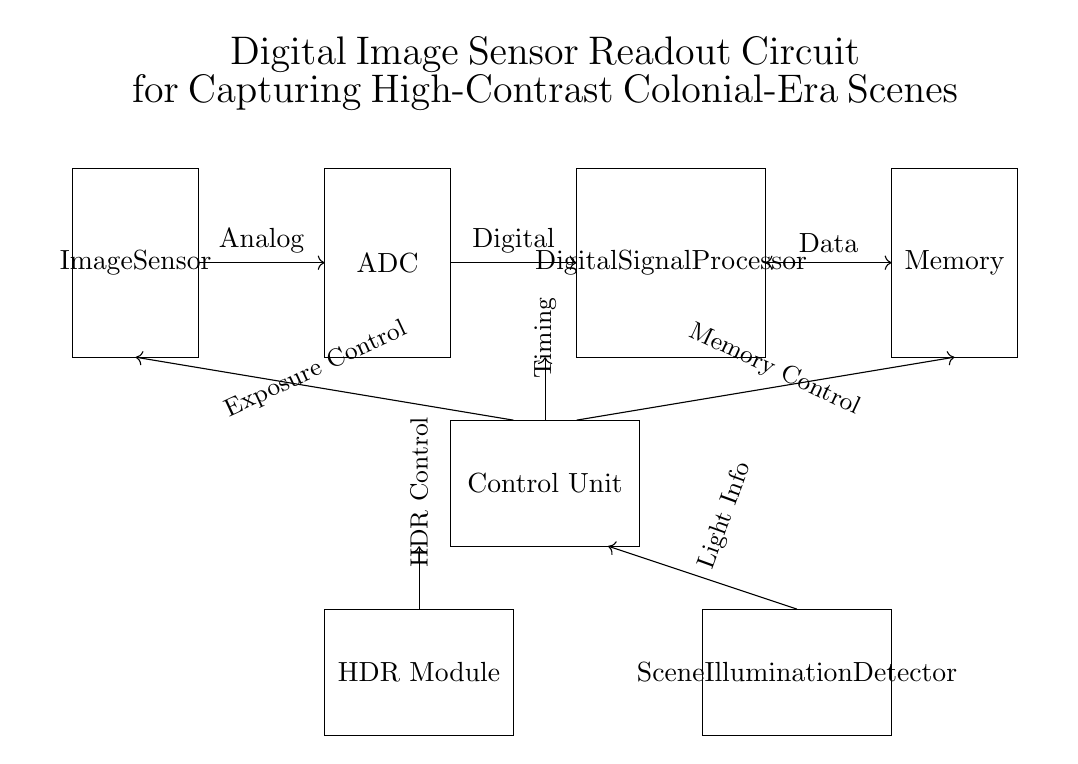What is the main function of the image sensor? The main function of the image sensor is to capture the incoming light from a scene and convert it into an electrical signal.
Answer: Capture light What type of module is responsible for high dynamic range processing? The HDR Module (High Dynamic Range Module) is specifically designed to enhance the details in high-contrast scenes by capturing and processing a greater range of luminance.
Answer: HDR Module How many primary components are in this circuit diagram? The primary components consist of the Image Sensor, ADC, Digital Signal Processor, Memory, Control Unit, HDR Module, and Scene Illumination Detector, totaling seven components.
Answer: Seven What connection does the ADC have with the image sensor? The ADC processes the analog signals coming from the image sensor, converting them into digital signals for further processing.
Answer: Analog Which component handles the timing for the circuit operations? The Control Unit manages timing, which is essential for synchronizing various operations in the circuit, including exposure control and memory control.
Answer: Control Unit What type of information does the Scene Illumination Detector provide? The Scene Illumination Detector provides light information that helps in adjusting the exposure settings for optimal image capture in varying lighting conditions.
Answer: Light Info 